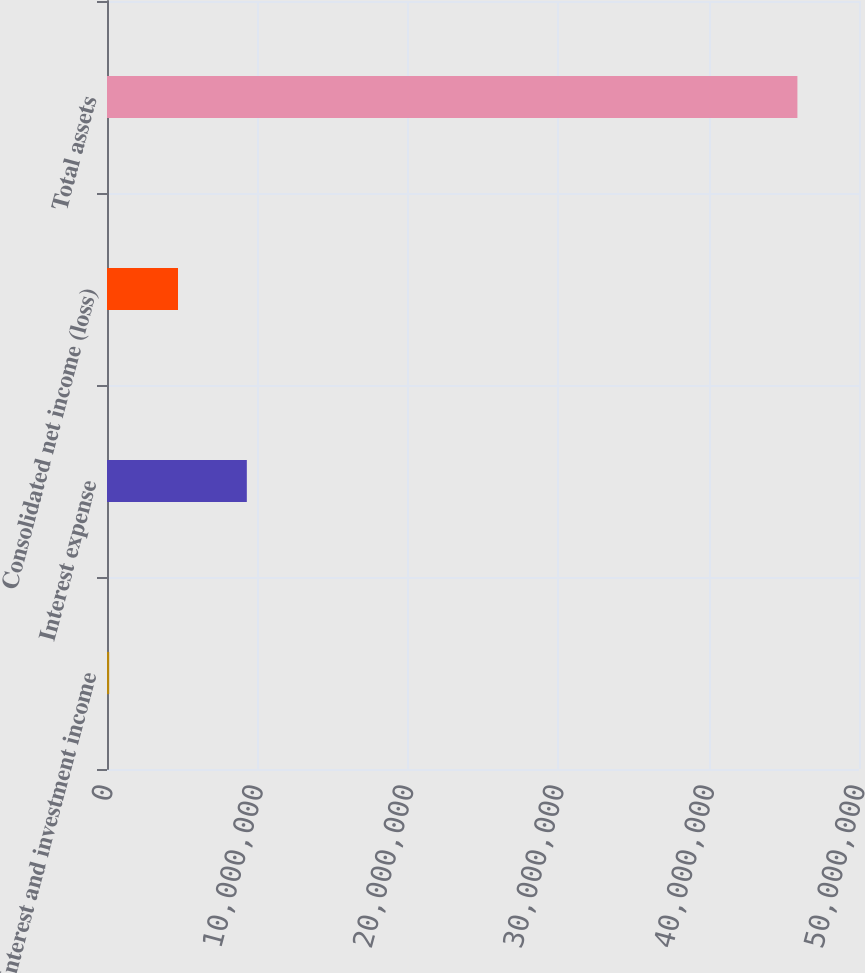<chart> <loc_0><loc_0><loc_500><loc_500><bar_chart><fcel>Interest and investment income<fcel>Interest expense<fcel>Consolidated net income (loss)<fcel>Total assets<nl><fcel>145127<fcel>9.29699e+06<fcel>4.72106e+06<fcel>4.59044e+07<nl></chart> 